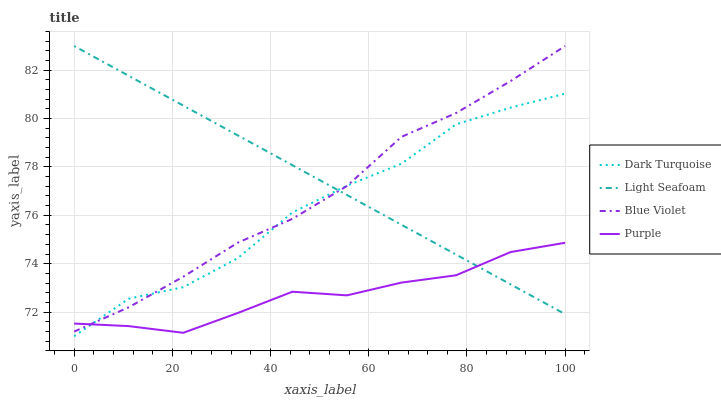Does Purple have the minimum area under the curve?
Answer yes or no. Yes. Does Light Seafoam have the maximum area under the curve?
Answer yes or no. Yes. Does Dark Turquoise have the minimum area under the curve?
Answer yes or no. No. Does Dark Turquoise have the maximum area under the curve?
Answer yes or no. No. Is Light Seafoam the smoothest?
Answer yes or no. Yes. Is Dark Turquoise the roughest?
Answer yes or no. Yes. Is Dark Turquoise the smoothest?
Answer yes or no. No. Is Light Seafoam the roughest?
Answer yes or no. No. Does Dark Turquoise have the lowest value?
Answer yes or no. Yes. Does Light Seafoam have the lowest value?
Answer yes or no. No. Does Blue Violet have the highest value?
Answer yes or no. Yes. Does Dark Turquoise have the highest value?
Answer yes or no. No. Does Purple intersect Blue Violet?
Answer yes or no. Yes. Is Purple less than Blue Violet?
Answer yes or no. No. Is Purple greater than Blue Violet?
Answer yes or no. No. 